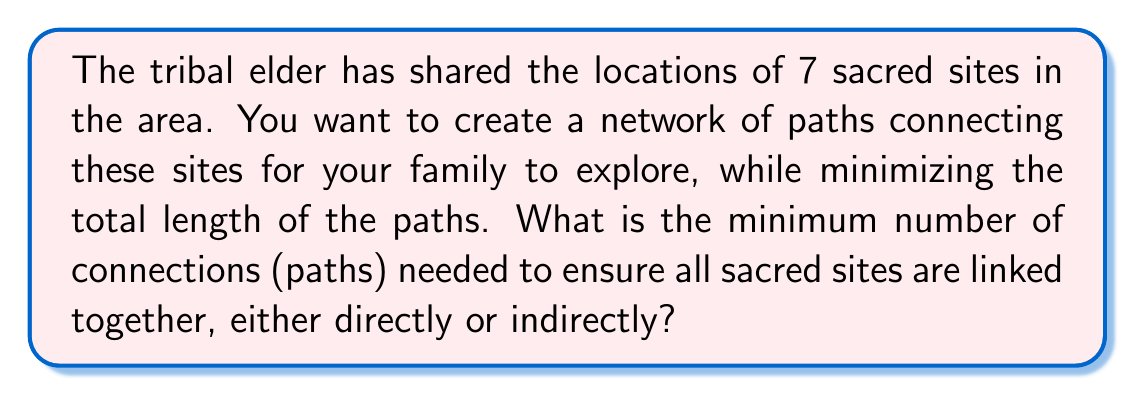Show me your answer to this math problem. This problem is a classic application of graph theory, specifically the concept of a minimum spanning tree. Here's how we can approach it:

1. Each sacred site can be considered a vertex in a graph.
2. The paths between sites are the edges of the graph.
3. We need to find a tree (a connected graph with no cycles) that spans all vertices.

The key theorem to remember is:

For a connected graph with $n$ vertices, a spanning tree always has exactly $n-1$ edges.

This is because:
- A tree with $n$ vertices always has $n-1$ edges.
- Adding one more edge would create a cycle, violating the definition of a tree.
- Removing any edge would disconnect the graph, violating the "spanning" property.

In this problem:
- We have 7 sacred sites, so $n = 7$.
- Therefore, the minimum number of connections needed is $n-1 = 7-1 = 6$.

This solution ensures that:
1. All sites are connected (either directly or indirectly).
2. There are no unnecessary connections (which would create cycles).

It's worth noting that while this gives us the number of connections, it doesn't specify which exact connections to make. In a real-world scenario, you would need additional information (like distances between sites) to determine the optimal set of connections.
Answer: 6 connections 